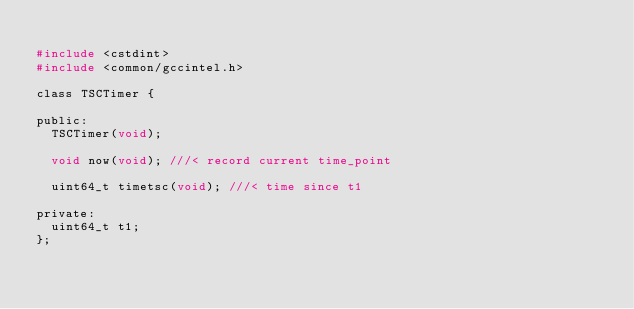<code> <loc_0><loc_0><loc_500><loc_500><_C_>
#include <cstdint>
#include <common/gccintel.h>

class TSCTimer {

public:
  TSCTimer(void);

  void now(void); ///< record current time_point

  uint64_t timetsc(void); ///< time since t1

private:
  uint64_t t1;
};
</code> 